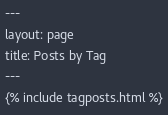<code> <loc_0><loc_0><loc_500><loc_500><_HTML_>---
layout: page
title: Posts by Tag
---
{% include tagposts.html %}
</code> 